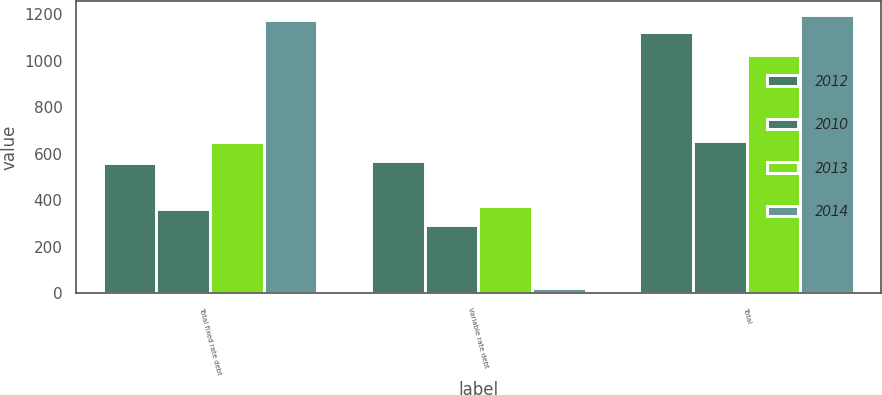Convert chart to OTSL. <chart><loc_0><loc_0><loc_500><loc_500><stacked_bar_chart><ecel><fcel>Total fixed rate debt<fcel>Variable rate debt<fcel>Total<nl><fcel>2012<fcel>559<fcel>567<fcel>1126<nl><fcel>2010<fcel>362<fcel>294<fcel>656<nl><fcel>2013<fcel>649<fcel>375<fcel>1024<nl><fcel>2014<fcel>1176<fcel>20<fcel>1196<nl></chart> 